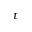<formula> <loc_0><loc_0><loc_500><loc_500>t</formula> 